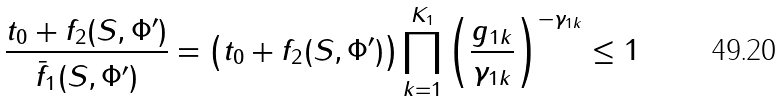Convert formula to latex. <formula><loc_0><loc_0><loc_500><loc_500>\frac { t _ { 0 } + f _ { 2 } ( S , \Phi ^ { \prime } ) } { \bar { f } _ { 1 } ( S , \Phi ^ { \prime } ) } = \left ( t _ { 0 } + f _ { 2 } ( S , \Phi ^ { \prime } ) \right ) \prod _ { k = 1 } ^ { K _ { 1 } } \left ( \frac { g _ { 1 k } } { \gamma _ { 1 k } } \right ) ^ { - \gamma _ { 1 k } } \leq 1</formula> 